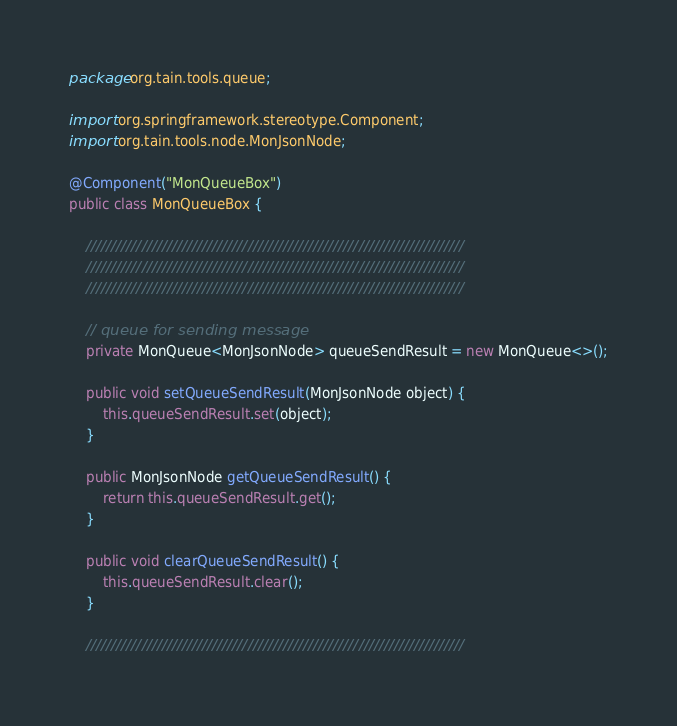Convert code to text. <code><loc_0><loc_0><loc_500><loc_500><_Java_>package org.tain.tools.queue;

import org.springframework.stereotype.Component;
import org.tain.tools.node.MonJsonNode;

@Component("MonQueueBox")
public class MonQueueBox {

	///////////////////////////////////////////////////////////////////////////
	///////////////////////////////////////////////////////////////////////////
	///////////////////////////////////////////////////////////////////////////
	
	// queue for sending message
	private MonQueue<MonJsonNode> queueSendResult = new MonQueue<>();
	
	public void setQueueSendResult(MonJsonNode object) {
		this.queueSendResult.set(object);
	}
	
	public MonJsonNode getQueueSendResult() {
		return this.queueSendResult.get();
	}
	
	public void clearQueueSendResult() {
		this.queueSendResult.clear();
	}
	
	///////////////////////////////////////////////////////////////////////////</code> 